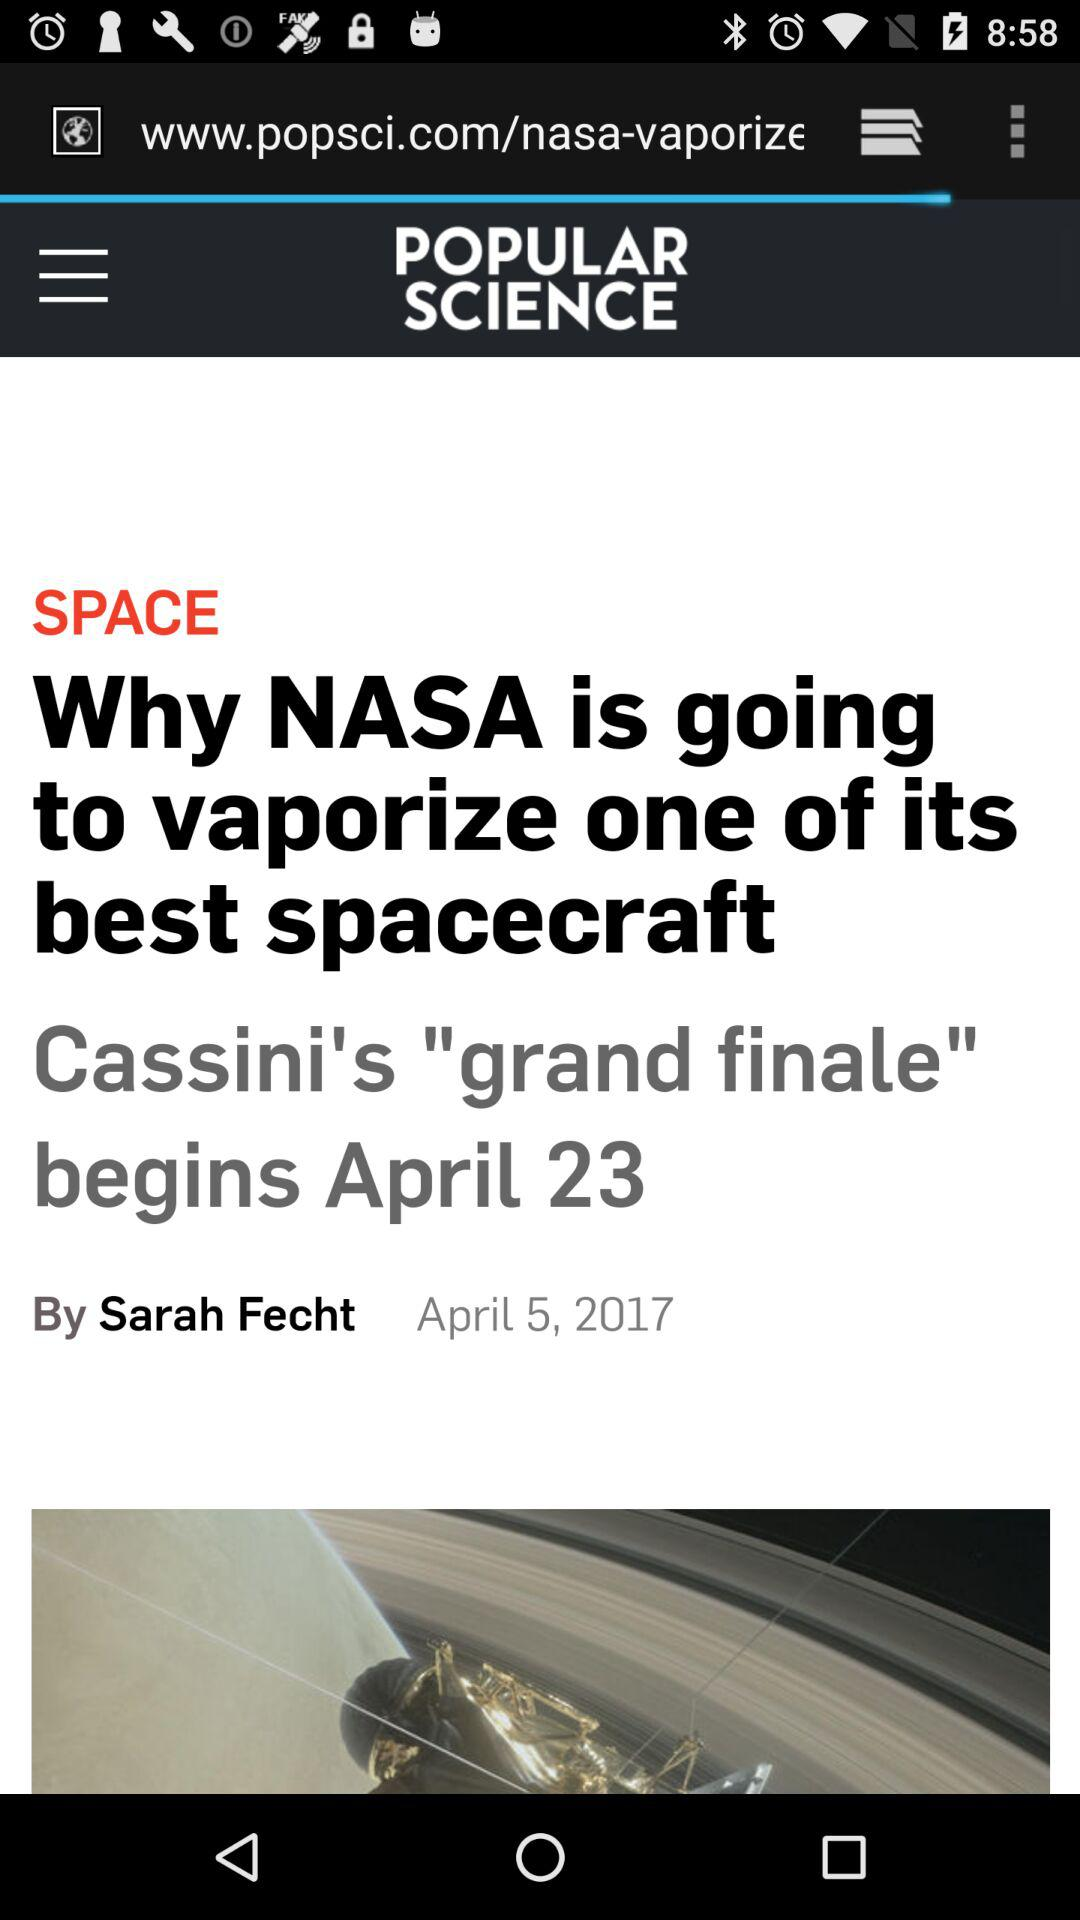What is the article's title? The article's title is "Why NASA is going to vaporize one of its best spacecraft". 